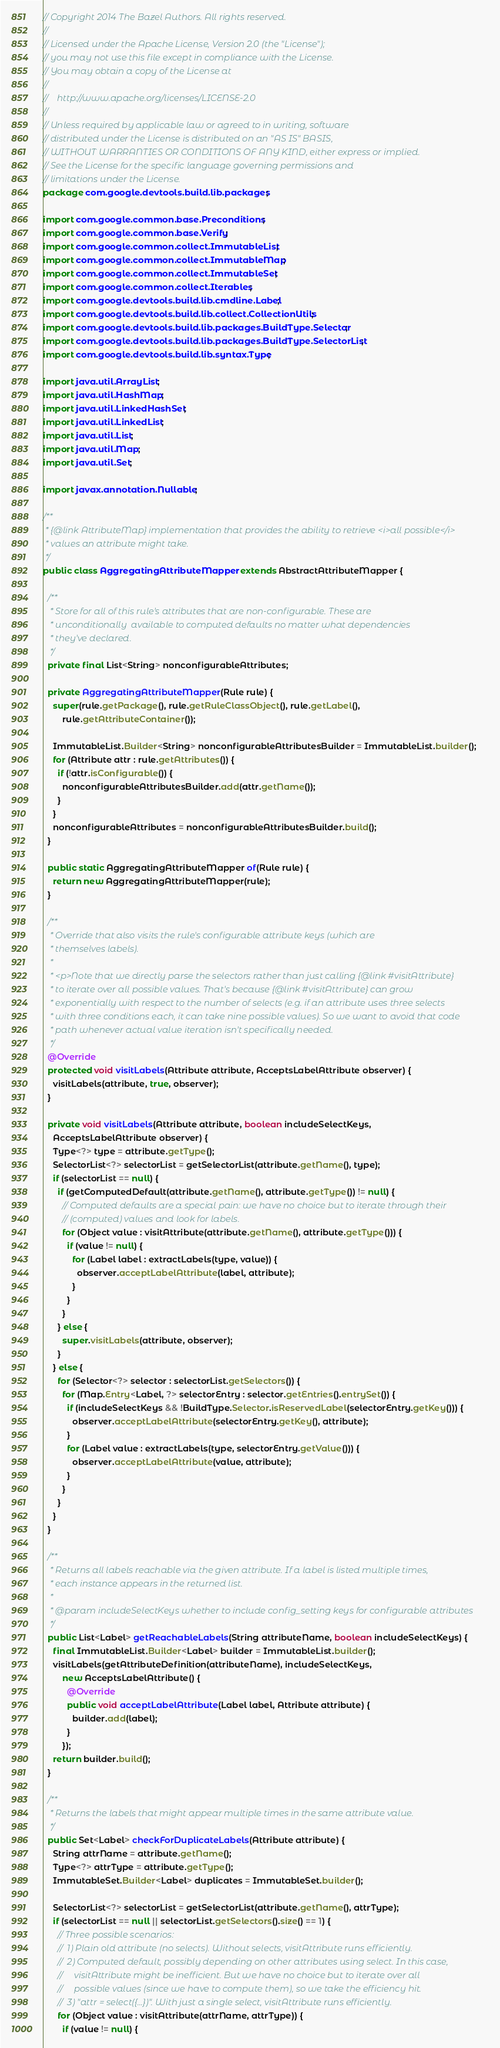Convert code to text. <code><loc_0><loc_0><loc_500><loc_500><_Java_>// Copyright 2014 The Bazel Authors. All rights reserved.
//
// Licensed under the Apache License, Version 2.0 (the "License");
// you may not use this file except in compliance with the License.
// You may obtain a copy of the License at
//
//    http://www.apache.org/licenses/LICENSE-2.0
//
// Unless required by applicable law or agreed to in writing, software
// distributed under the License is distributed on an "AS IS" BASIS,
// WITHOUT WARRANTIES OR CONDITIONS OF ANY KIND, either express or implied.
// See the License for the specific language governing permissions and
// limitations under the License.
package com.google.devtools.build.lib.packages;

import com.google.common.base.Preconditions;
import com.google.common.base.Verify;
import com.google.common.collect.ImmutableList;
import com.google.common.collect.ImmutableMap;
import com.google.common.collect.ImmutableSet;
import com.google.common.collect.Iterables;
import com.google.devtools.build.lib.cmdline.Label;
import com.google.devtools.build.lib.collect.CollectionUtils;
import com.google.devtools.build.lib.packages.BuildType.Selector;
import com.google.devtools.build.lib.packages.BuildType.SelectorList;
import com.google.devtools.build.lib.syntax.Type;

import java.util.ArrayList;
import java.util.HashMap;
import java.util.LinkedHashSet;
import java.util.LinkedList;
import java.util.List;
import java.util.Map;
import java.util.Set;

import javax.annotation.Nullable;

/**
 * {@link AttributeMap} implementation that provides the ability to retrieve <i>all possible</i>
 * values an attribute might take.
 */
public class AggregatingAttributeMapper extends AbstractAttributeMapper {

  /**
   * Store for all of this rule's attributes that are non-configurable. These are
   * unconditionally  available to computed defaults no matter what dependencies
   * they've declared.
   */
  private final List<String> nonconfigurableAttributes;

  private AggregatingAttributeMapper(Rule rule) {
    super(rule.getPackage(), rule.getRuleClassObject(), rule.getLabel(),
        rule.getAttributeContainer());

    ImmutableList.Builder<String> nonconfigurableAttributesBuilder = ImmutableList.builder();
    for (Attribute attr : rule.getAttributes()) {
      if (!attr.isConfigurable()) {
        nonconfigurableAttributesBuilder.add(attr.getName());
      }
    }
    nonconfigurableAttributes = nonconfigurableAttributesBuilder.build();
  }

  public static AggregatingAttributeMapper of(Rule rule) {
    return new AggregatingAttributeMapper(rule);
  }

  /**
   * Override that also visits the rule's configurable attribute keys (which are
   * themselves labels).
   *
   * <p>Note that we directly parse the selectors rather than just calling {@link #visitAttribute}
   * to iterate over all possible values. That's because {@link #visitAttribute} can grow
   * exponentially with respect to the number of selects (e.g. if an attribute uses three selects
   * with three conditions each, it can take nine possible values). So we want to avoid that code
   * path whenever actual value iteration isn't specifically needed.
   */
  @Override
  protected void visitLabels(Attribute attribute, AcceptsLabelAttribute observer) {
    visitLabels(attribute, true, observer);
  }

  private void visitLabels(Attribute attribute, boolean includeSelectKeys,
    AcceptsLabelAttribute observer) {
    Type<?> type = attribute.getType();
    SelectorList<?> selectorList = getSelectorList(attribute.getName(), type);
    if (selectorList == null) {
      if (getComputedDefault(attribute.getName(), attribute.getType()) != null) {
        // Computed defaults are a special pain: we have no choice but to iterate through their
        // (computed) values and look for labels.
        for (Object value : visitAttribute(attribute.getName(), attribute.getType())) {
          if (value != null) {
            for (Label label : extractLabels(type, value)) {
              observer.acceptLabelAttribute(label, attribute);
            }
          }
        }
      } else {
        super.visitLabels(attribute, observer);
      }
    } else {
      for (Selector<?> selector : selectorList.getSelectors()) {
        for (Map.Entry<Label, ?> selectorEntry : selector.getEntries().entrySet()) {
          if (includeSelectKeys && !BuildType.Selector.isReservedLabel(selectorEntry.getKey())) {
            observer.acceptLabelAttribute(selectorEntry.getKey(), attribute);
          }
          for (Label value : extractLabels(type, selectorEntry.getValue())) {
            observer.acceptLabelAttribute(value, attribute);
          }
        }
      }
    }
  }

  /**
   * Returns all labels reachable via the given attribute. If a label is listed multiple times,
   * each instance appears in the returned list.
   *
   * @param includeSelectKeys whether to include config_setting keys for configurable attributes
   */
  public List<Label> getReachableLabels(String attributeName, boolean includeSelectKeys) {
    final ImmutableList.Builder<Label> builder = ImmutableList.builder();
    visitLabels(getAttributeDefinition(attributeName), includeSelectKeys,
        new AcceptsLabelAttribute() {
          @Override
          public void acceptLabelAttribute(Label label, Attribute attribute) {
            builder.add(label);
          }
        });
    return builder.build();
  }

  /**
   * Returns the labels that might appear multiple times in the same attribute value.
   */
  public Set<Label> checkForDuplicateLabels(Attribute attribute) {
    String attrName = attribute.getName();
    Type<?> attrType = attribute.getType();
    ImmutableSet.Builder<Label> duplicates = ImmutableSet.builder();

    SelectorList<?> selectorList = getSelectorList(attribute.getName(), attrType);
    if (selectorList == null || selectorList.getSelectors().size() == 1) {
      // Three possible scenarios:
      //  1) Plain old attribute (no selects). Without selects, visitAttribute runs efficiently.
      //  2) Computed default, possibly depending on other attributes using select. In this case,
      //     visitAttribute might be inefficient. But we have no choice but to iterate over all
      //     possible values (since we have to compute them), so we take the efficiency hit.
      //  3) "attr = select({...})". With just a single select, visitAttribute runs efficiently.
      for (Object value : visitAttribute(attrName, attrType)) {
        if (value != null) {</code> 